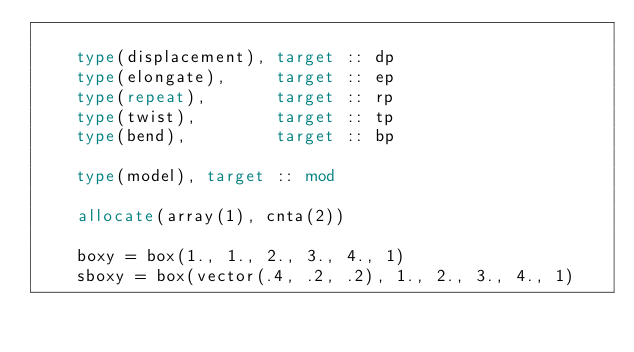Convert code to text. <code><loc_0><loc_0><loc_500><loc_500><_FORTRAN_>
    type(displacement), target :: dp
    type(elongate),     target :: ep
    type(repeat),       target :: rp
    type(twist),        target :: tp
    type(bend),         target :: bp

    type(model), target :: mod

    allocate(array(1), cnta(2))

    boxy = box(1., 1., 2., 3., 4., 1)
    sboxy = box(vector(.4, .2, .2), 1., 2., 3., 4., 1)</code> 